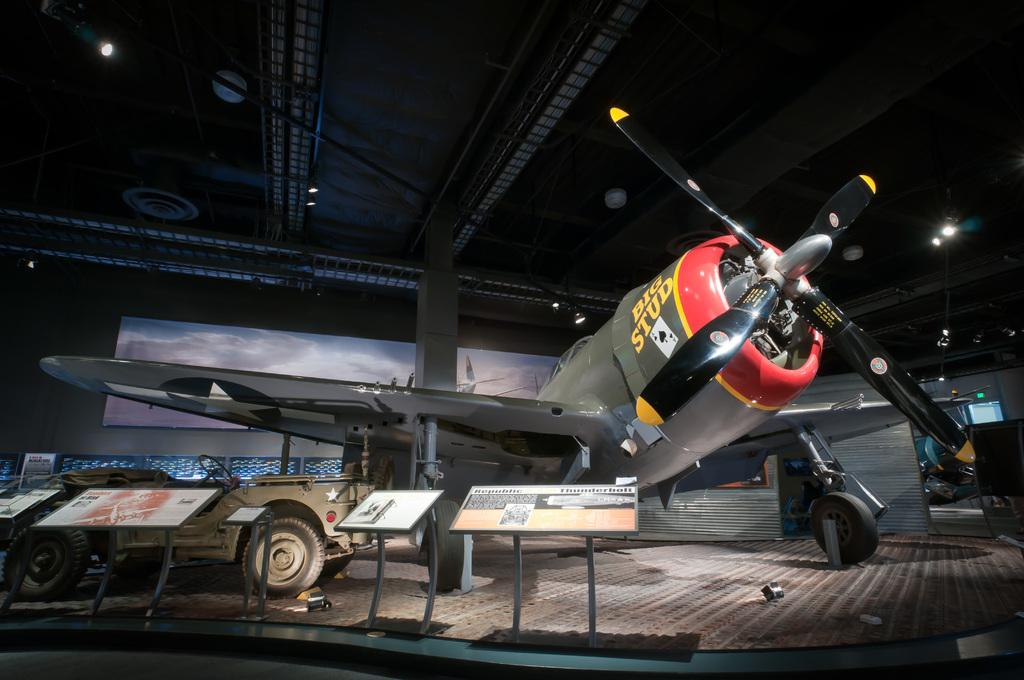What is the main subject of the image? The main subject of the image is a flight. Where is the flight located in the image? The flight is kept in a closed area. What can be seen beside the flight in the image? There are boards placed beside the flight. What is the purpose of the boards beside the flight? The boards contain information and images. What type of steel is used to construct the potato in the image? There is no potato or steel present in the image; it features a flight in a closed area with boards containing information and images. 